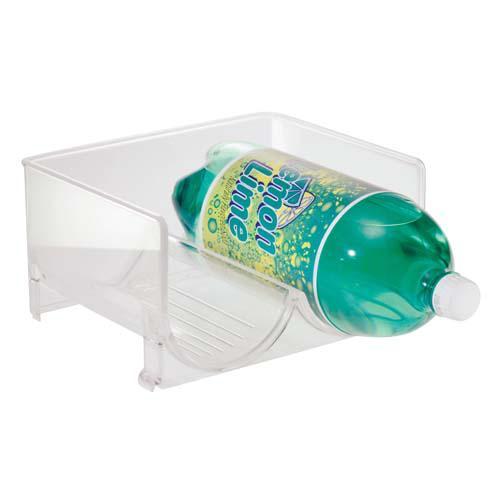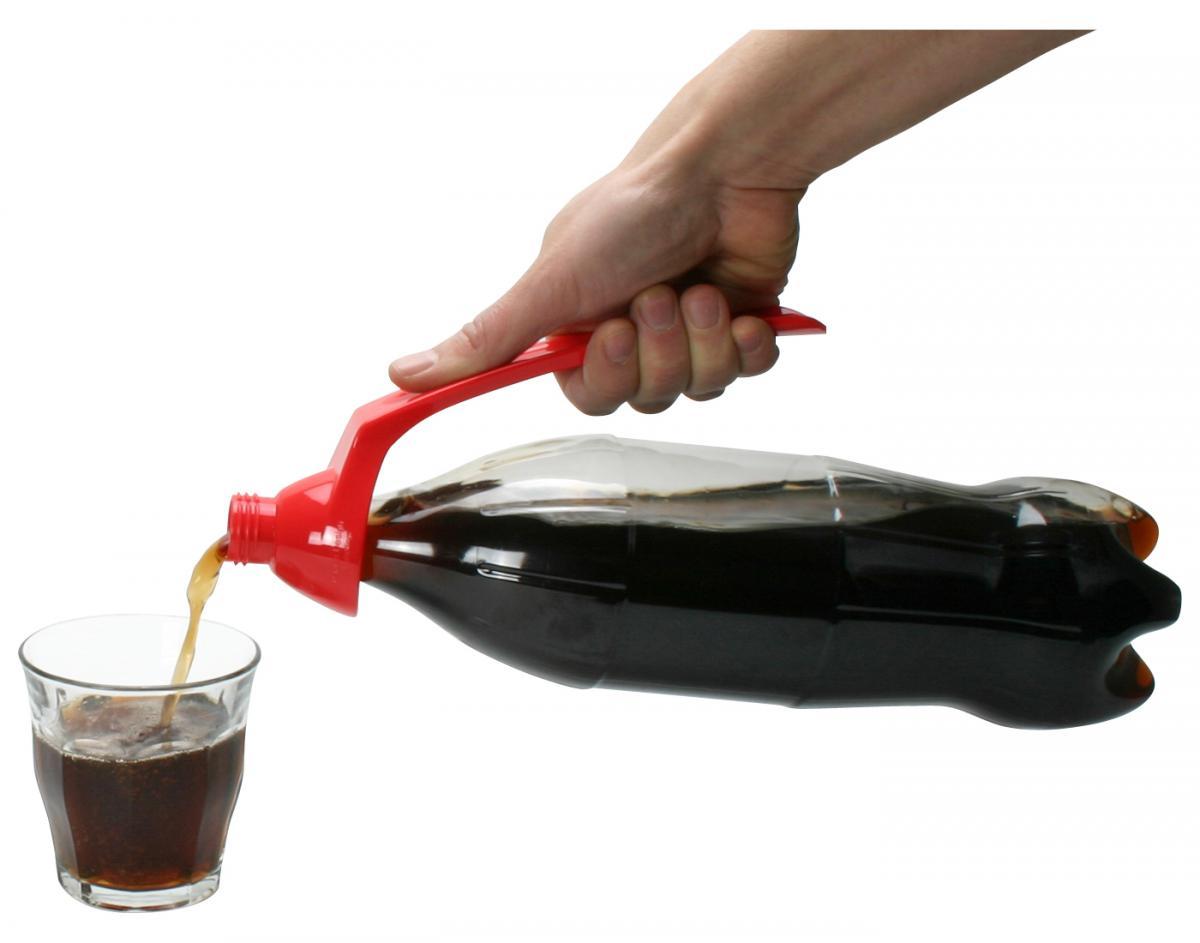The first image is the image on the left, the second image is the image on the right. Examine the images to the left and right. Is the description "A person is pouring out the soda in one of the images." accurate? Answer yes or no. Yes. The first image is the image on the left, the second image is the image on the right. Considering the images on both sides, is "An image shows one hand gripping a handle attached to a horizontal bottle pouring cola into a glass under it on the left." valid? Answer yes or no. Yes. 